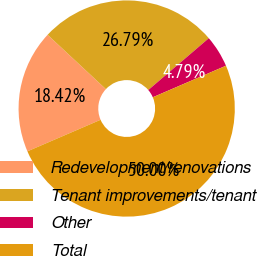<chart> <loc_0><loc_0><loc_500><loc_500><pie_chart><fcel>Redevelopment/renovations<fcel>Tenant improvements/tenant<fcel>Other<fcel>Total<nl><fcel>18.42%<fcel>26.79%<fcel>4.79%<fcel>50.0%<nl></chart> 